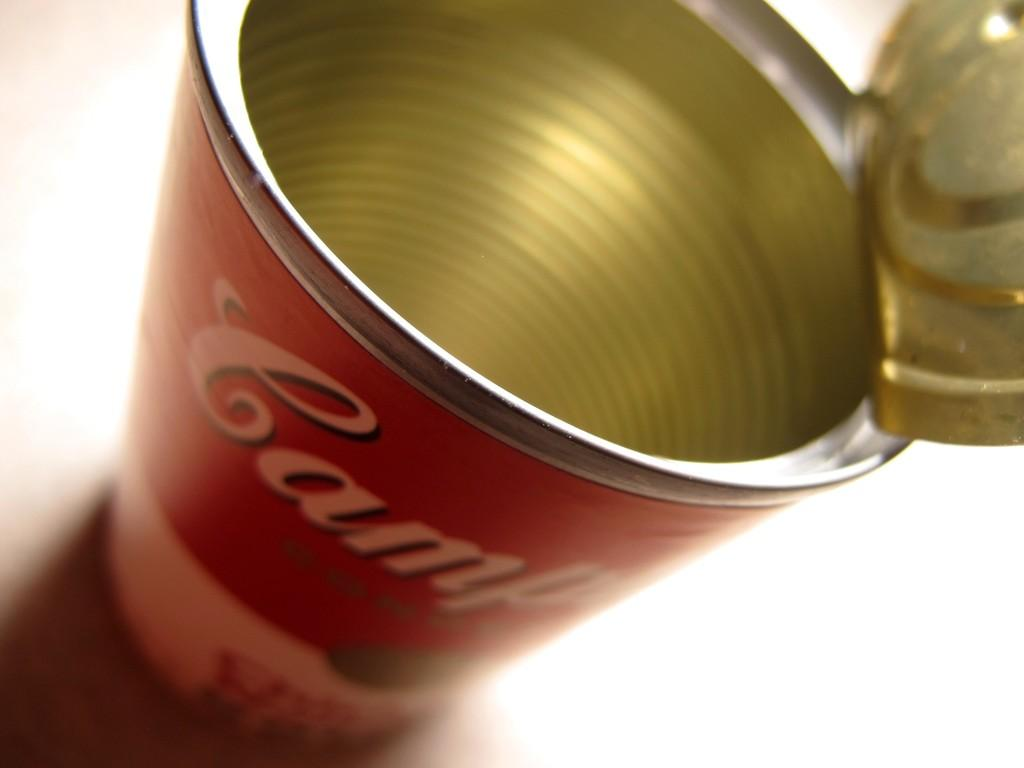What object is the main focus of the image? There is a can in the image. What can be found on the surface of the can? The can has text on it. Can you describe the background of the image? The background of the image is blurred. What type of oatmeal is being prepared in the image? There is no oatmeal or preparation process visible in the image; it only features a can with text on it. 